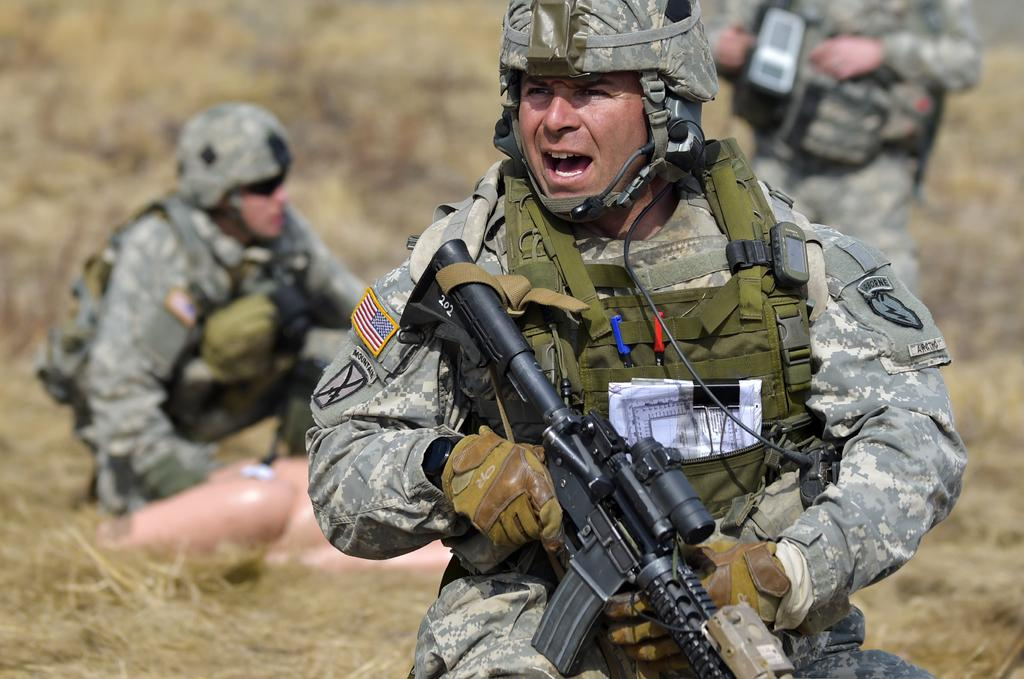How many people are in the image? There is a group of people in the image. What are some of the people in the group holding? Some people in the group are holding guns. What can be seen in the background of the image? There is grass visible in the background of the image. What type of pets can be seen playing with the oven in the image? There are no pets or ovens present in the image. 